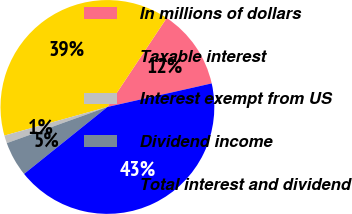Convert chart to OTSL. <chart><loc_0><loc_0><loc_500><loc_500><pie_chart><fcel>In millions of dollars<fcel>Taxable interest<fcel>Interest exempt from US<fcel>Dividend income<fcel>Total interest and dividend<nl><fcel>12.11%<fcel>38.67%<fcel>1.18%<fcel>5.28%<fcel>42.77%<nl></chart> 